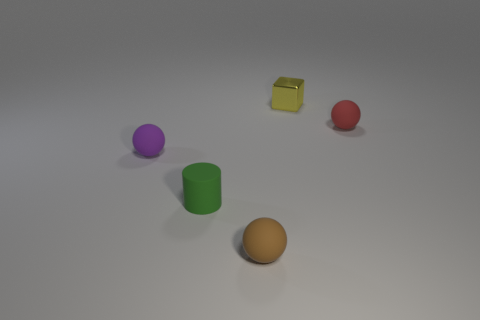Is the material of the sphere that is to the left of the brown rubber sphere the same as the tiny green object?
Your answer should be very brief. Yes. Is there any other thing that is the same material as the tiny yellow block?
Keep it short and to the point. No. How big is the object behind the tiny ball behind the purple object?
Your answer should be very brief. Small. There is a thing behind the tiny matte sphere right of the object behind the tiny red ball; how big is it?
Make the answer very short. Small. Does the small rubber thing that is behind the tiny purple matte thing have the same shape as the object that is on the left side of the small green object?
Keep it short and to the point. Yes. There is a sphere that is behind the purple ball; is it the same size as the small purple ball?
Ensure brevity in your answer.  Yes. Do the small ball that is in front of the green cylinder and the sphere left of the cylinder have the same material?
Your answer should be compact. Yes. Are there any purple spheres of the same size as the brown rubber thing?
Provide a succinct answer. Yes. There is a small thing behind the small object to the right of the tiny thing behind the red thing; what shape is it?
Make the answer very short. Cube. Is the number of small brown matte things that are in front of the small metallic thing greater than the number of small purple cubes?
Offer a terse response. Yes. 